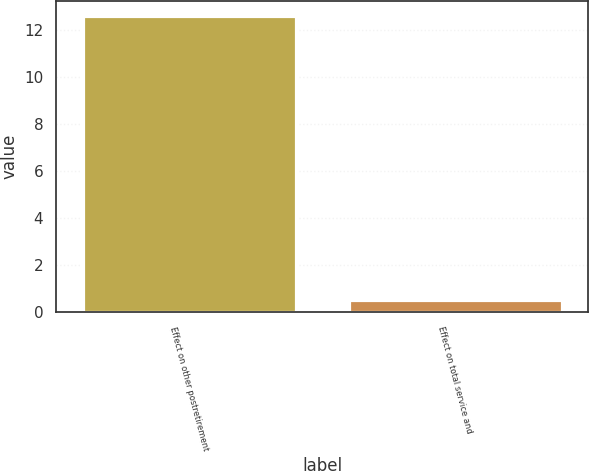Convert chart. <chart><loc_0><loc_0><loc_500><loc_500><bar_chart><fcel>Effect on other postretirement<fcel>Effect on total service and<nl><fcel>12.6<fcel>0.5<nl></chart> 